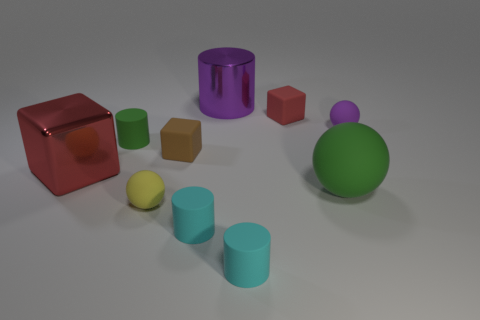Subtract all small green cylinders. How many cylinders are left? 3 Subtract all purple spheres. How many spheres are left? 2 Subtract all cyan blocks. Subtract all cyan spheres. How many blocks are left? 3 Subtract all blue blocks. How many red spheres are left? 0 Add 2 yellow rubber spheres. How many yellow rubber spheres exist? 3 Subtract 2 cyan cylinders. How many objects are left? 8 Subtract all blocks. How many objects are left? 7 Subtract 2 balls. How many balls are left? 1 Subtract all small purple things. Subtract all big purple metal cylinders. How many objects are left? 8 Add 1 large purple things. How many large purple things are left? 2 